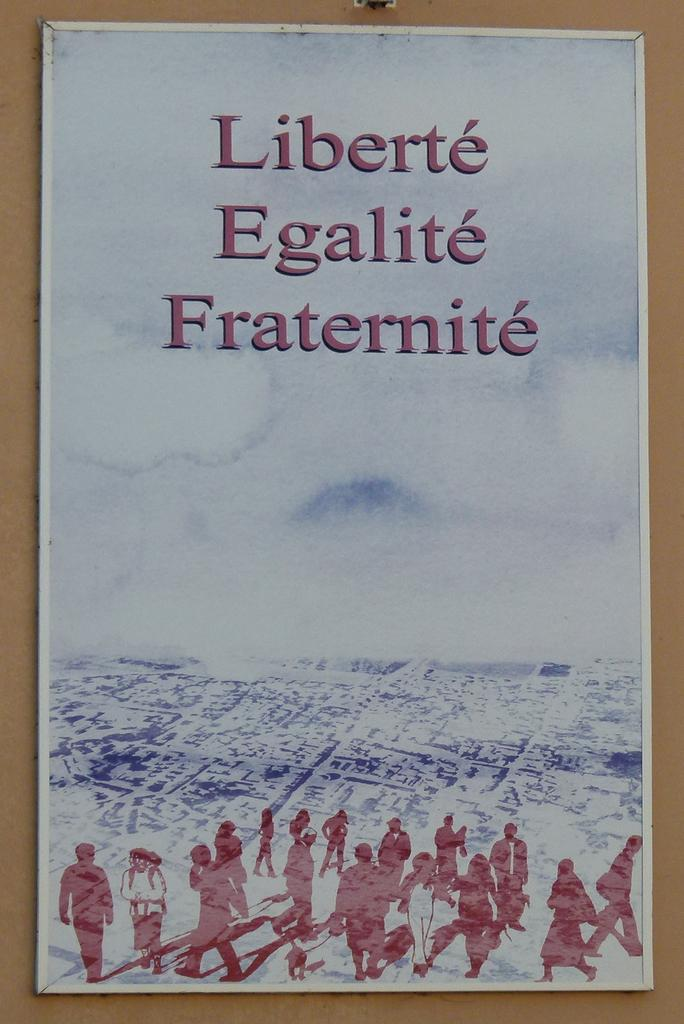<image>
Create a compact narrative representing the image presented. A poster that says Liberte, Egalite and Fraternite. 